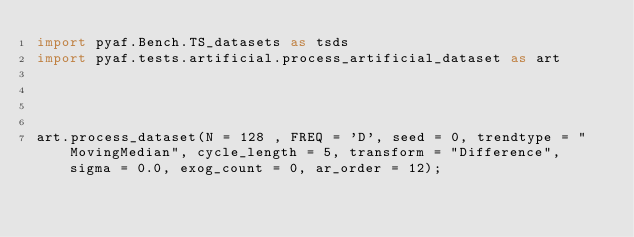<code> <loc_0><loc_0><loc_500><loc_500><_Python_>import pyaf.Bench.TS_datasets as tsds
import pyaf.tests.artificial.process_artificial_dataset as art




art.process_dataset(N = 128 , FREQ = 'D', seed = 0, trendtype = "MovingMedian", cycle_length = 5, transform = "Difference", sigma = 0.0, exog_count = 0, ar_order = 12);</code> 